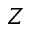<formula> <loc_0><loc_0><loc_500><loc_500>Z</formula> 